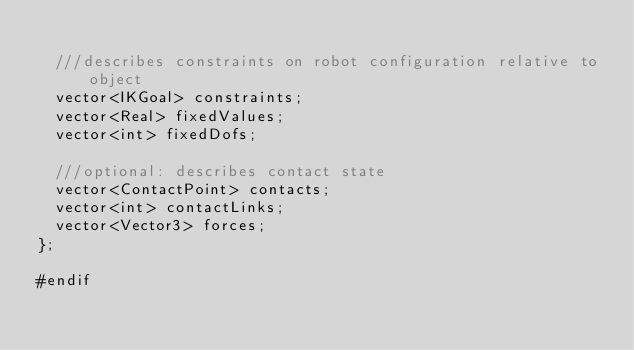<code> <loc_0><loc_0><loc_500><loc_500><_C_>
  ///describes constraints on robot configuration relative to object
  vector<IKGoal> constraints;
  vector<Real> fixedValues;
  vector<int> fixedDofs;

  ///optional: describes contact state
  vector<ContactPoint> contacts;
  vector<int> contactLinks;
  vector<Vector3> forces;
};

#endif
</code> 